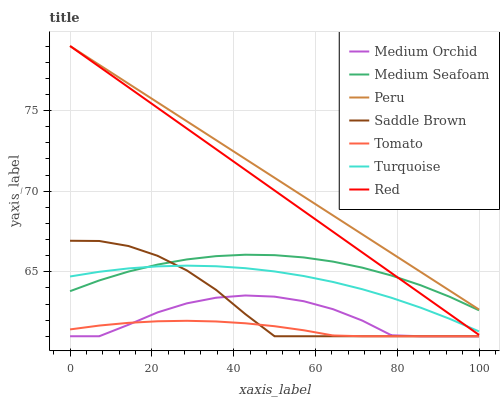Does Tomato have the minimum area under the curve?
Answer yes or no. Yes. Does Peru have the maximum area under the curve?
Answer yes or no. Yes. Does Turquoise have the minimum area under the curve?
Answer yes or no. No. Does Turquoise have the maximum area under the curve?
Answer yes or no. No. Is Red the smoothest?
Answer yes or no. Yes. Is Medium Orchid the roughest?
Answer yes or no. Yes. Is Turquoise the smoothest?
Answer yes or no. No. Is Turquoise the roughest?
Answer yes or no. No. Does Turquoise have the lowest value?
Answer yes or no. No. Does Red have the highest value?
Answer yes or no. Yes. Does Turquoise have the highest value?
Answer yes or no. No. Is Saddle Brown less than Red?
Answer yes or no. Yes. Is Medium Seafoam greater than Tomato?
Answer yes or no. Yes. Does Medium Orchid intersect Tomato?
Answer yes or no. Yes. Is Medium Orchid less than Tomato?
Answer yes or no. No. Is Medium Orchid greater than Tomato?
Answer yes or no. No. Does Saddle Brown intersect Red?
Answer yes or no. No. 